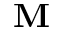Convert formula to latex. <formula><loc_0><loc_0><loc_500><loc_500>M</formula> 